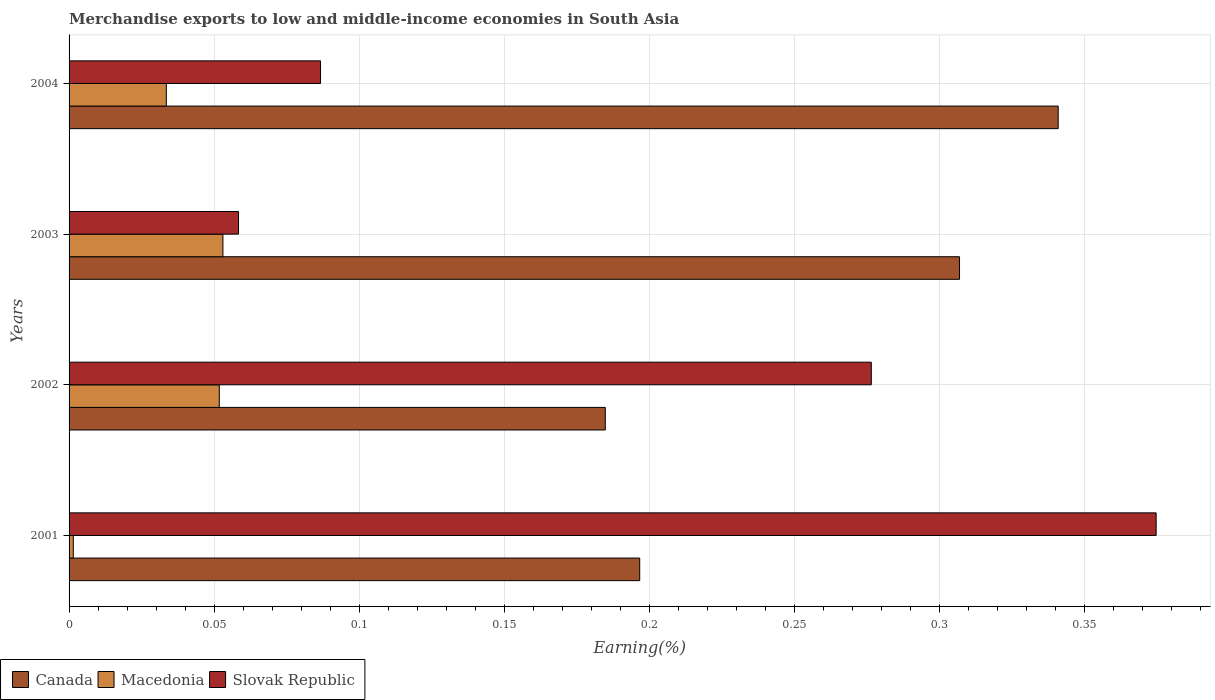Are the number of bars on each tick of the Y-axis equal?
Give a very brief answer. Yes. How many bars are there on the 1st tick from the top?
Ensure brevity in your answer.  3. What is the percentage of amount earned from merchandise exports in Canada in 2002?
Your response must be concise. 0.18. Across all years, what is the maximum percentage of amount earned from merchandise exports in Macedonia?
Make the answer very short. 0.05. Across all years, what is the minimum percentage of amount earned from merchandise exports in Macedonia?
Offer a very short reply. 0. What is the total percentage of amount earned from merchandise exports in Canada in the graph?
Ensure brevity in your answer.  1.03. What is the difference between the percentage of amount earned from merchandise exports in Macedonia in 2001 and that in 2003?
Your response must be concise. -0.05. What is the difference between the percentage of amount earned from merchandise exports in Canada in 2001 and the percentage of amount earned from merchandise exports in Slovak Republic in 2003?
Your answer should be compact. 0.14. What is the average percentage of amount earned from merchandise exports in Macedonia per year?
Your answer should be compact. 0.03. In the year 2001, what is the difference between the percentage of amount earned from merchandise exports in Canada and percentage of amount earned from merchandise exports in Macedonia?
Offer a very short reply. 0.2. What is the ratio of the percentage of amount earned from merchandise exports in Slovak Republic in 2001 to that in 2003?
Ensure brevity in your answer.  6.42. Is the difference between the percentage of amount earned from merchandise exports in Canada in 2001 and 2003 greater than the difference between the percentage of amount earned from merchandise exports in Macedonia in 2001 and 2003?
Give a very brief answer. No. What is the difference between the highest and the second highest percentage of amount earned from merchandise exports in Slovak Republic?
Keep it short and to the point. 0.1. What is the difference between the highest and the lowest percentage of amount earned from merchandise exports in Macedonia?
Offer a very short reply. 0.05. What does the 1st bar from the top in 2004 represents?
Offer a terse response. Slovak Republic. What does the 2nd bar from the bottom in 2003 represents?
Ensure brevity in your answer.  Macedonia. How many bars are there?
Your answer should be very brief. 12. Does the graph contain grids?
Ensure brevity in your answer.  Yes. What is the title of the graph?
Your response must be concise. Merchandise exports to low and middle-income economies in South Asia. What is the label or title of the X-axis?
Keep it short and to the point. Earning(%). What is the label or title of the Y-axis?
Your response must be concise. Years. What is the Earning(%) of Canada in 2001?
Keep it short and to the point. 0.2. What is the Earning(%) of Macedonia in 2001?
Provide a short and direct response. 0. What is the Earning(%) of Slovak Republic in 2001?
Your answer should be compact. 0.37. What is the Earning(%) of Canada in 2002?
Keep it short and to the point. 0.18. What is the Earning(%) of Macedonia in 2002?
Provide a succinct answer. 0.05. What is the Earning(%) of Slovak Republic in 2002?
Your answer should be very brief. 0.28. What is the Earning(%) in Canada in 2003?
Make the answer very short. 0.31. What is the Earning(%) of Macedonia in 2003?
Provide a succinct answer. 0.05. What is the Earning(%) of Slovak Republic in 2003?
Your answer should be compact. 0.06. What is the Earning(%) in Canada in 2004?
Keep it short and to the point. 0.34. What is the Earning(%) in Macedonia in 2004?
Make the answer very short. 0.03. What is the Earning(%) in Slovak Republic in 2004?
Give a very brief answer. 0.09. Across all years, what is the maximum Earning(%) of Canada?
Give a very brief answer. 0.34. Across all years, what is the maximum Earning(%) of Macedonia?
Give a very brief answer. 0.05. Across all years, what is the maximum Earning(%) of Slovak Republic?
Your response must be concise. 0.37. Across all years, what is the minimum Earning(%) in Canada?
Provide a succinct answer. 0.18. Across all years, what is the minimum Earning(%) of Macedonia?
Provide a short and direct response. 0. Across all years, what is the minimum Earning(%) of Slovak Republic?
Keep it short and to the point. 0.06. What is the total Earning(%) in Canada in the graph?
Ensure brevity in your answer.  1.03. What is the total Earning(%) in Macedonia in the graph?
Offer a terse response. 0.14. What is the total Earning(%) of Slovak Republic in the graph?
Your answer should be very brief. 0.8. What is the difference between the Earning(%) in Canada in 2001 and that in 2002?
Ensure brevity in your answer.  0.01. What is the difference between the Earning(%) in Macedonia in 2001 and that in 2002?
Keep it short and to the point. -0.05. What is the difference between the Earning(%) of Slovak Republic in 2001 and that in 2002?
Provide a short and direct response. 0.1. What is the difference between the Earning(%) of Canada in 2001 and that in 2003?
Your response must be concise. -0.11. What is the difference between the Earning(%) of Macedonia in 2001 and that in 2003?
Ensure brevity in your answer.  -0.05. What is the difference between the Earning(%) in Slovak Republic in 2001 and that in 2003?
Provide a succinct answer. 0.32. What is the difference between the Earning(%) of Canada in 2001 and that in 2004?
Your answer should be very brief. -0.14. What is the difference between the Earning(%) of Macedonia in 2001 and that in 2004?
Your answer should be very brief. -0.03. What is the difference between the Earning(%) in Slovak Republic in 2001 and that in 2004?
Your response must be concise. 0.29. What is the difference between the Earning(%) of Canada in 2002 and that in 2003?
Offer a terse response. -0.12. What is the difference between the Earning(%) of Macedonia in 2002 and that in 2003?
Provide a succinct answer. -0. What is the difference between the Earning(%) of Slovak Republic in 2002 and that in 2003?
Make the answer very short. 0.22. What is the difference between the Earning(%) of Canada in 2002 and that in 2004?
Your answer should be compact. -0.16. What is the difference between the Earning(%) of Macedonia in 2002 and that in 2004?
Offer a very short reply. 0.02. What is the difference between the Earning(%) of Slovak Republic in 2002 and that in 2004?
Ensure brevity in your answer.  0.19. What is the difference between the Earning(%) of Canada in 2003 and that in 2004?
Offer a terse response. -0.03. What is the difference between the Earning(%) in Macedonia in 2003 and that in 2004?
Make the answer very short. 0.02. What is the difference between the Earning(%) of Slovak Republic in 2003 and that in 2004?
Offer a terse response. -0.03. What is the difference between the Earning(%) in Canada in 2001 and the Earning(%) in Macedonia in 2002?
Offer a very short reply. 0.14. What is the difference between the Earning(%) in Canada in 2001 and the Earning(%) in Slovak Republic in 2002?
Make the answer very short. -0.08. What is the difference between the Earning(%) in Macedonia in 2001 and the Earning(%) in Slovak Republic in 2002?
Your answer should be compact. -0.28. What is the difference between the Earning(%) of Canada in 2001 and the Earning(%) of Macedonia in 2003?
Ensure brevity in your answer.  0.14. What is the difference between the Earning(%) in Canada in 2001 and the Earning(%) in Slovak Republic in 2003?
Provide a succinct answer. 0.14. What is the difference between the Earning(%) of Macedonia in 2001 and the Earning(%) of Slovak Republic in 2003?
Your answer should be very brief. -0.06. What is the difference between the Earning(%) in Canada in 2001 and the Earning(%) in Macedonia in 2004?
Provide a succinct answer. 0.16. What is the difference between the Earning(%) of Canada in 2001 and the Earning(%) of Slovak Republic in 2004?
Keep it short and to the point. 0.11. What is the difference between the Earning(%) of Macedonia in 2001 and the Earning(%) of Slovak Republic in 2004?
Offer a very short reply. -0.09. What is the difference between the Earning(%) in Canada in 2002 and the Earning(%) in Macedonia in 2003?
Offer a very short reply. 0.13. What is the difference between the Earning(%) of Canada in 2002 and the Earning(%) of Slovak Republic in 2003?
Offer a terse response. 0.13. What is the difference between the Earning(%) in Macedonia in 2002 and the Earning(%) in Slovak Republic in 2003?
Your answer should be compact. -0.01. What is the difference between the Earning(%) in Canada in 2002 and the Earning(%) in Macedonia in 2004?
Provide a succinct answer. 0.15. What is the difference between the Earning(%) in Canada in 2002 and the Earning(%) in Slovak Republic in 2004?
Provide a short and direct response. 0.1. What is the difference between the Earning(%) of Macedonia in 2002 and the Earning(%) of Slovak Republic in 2004?
Offer a terse response. -0.03. What is the difference between the Earning(%) of Canada in 2003 and the Earning(%) of Macedonia in 2004?
Keep it short and to the point. 0.27. What is the difference between the Earning(%) in Canada in 2003 and the Earning(%) in Slovak Republic in 2004?
Offer a very short reply. 0.22. What is the difference between the Earning(%) in Macedonia in 2003 and the Earning(%) in Slovak Republic in 2004?
Make the answer very short. -0.03. What is the average Earning(%) in Canada per year?
Offer a terse response. 0.26. What is the average Earning(%) in Macedonia per year?
Your response must be concise. 0.04. What is the average Earning(%) in Slovak Republic per year?
Make the answer very short. 0.2. In the year 2001, what is the difference between the Earning(%) of Canada and Earning(%) of Macedonia?
Your response must be concise. 0.2. In the year 2001, what is the difference between the Earning(%) of Canada and Earning(%) of Slovak Republic?
Offer a very short reply. -0.18. In the year 2001, what is the difference between the Earning(%) in Macedonia and Earning(%) in Slovak Republic?
Offer a terse response. -0.37. In the year 2002, what is the difference between the Earning(%) in Canada and Earning(%) in Macedonia?
Make the answer very short. 0.13. In the year 2002, what is the difference between the Earning(%) of Canada and Earning(%) of Slovak Republic?
Give a very brief answer. -0.09. In the year 2002, what is the difference between the Earning(%) in Macedonia and Earning(%) in Slovak Republic?
Offer a very short reply. -0.22. In the year 2003, what is the difference between the Earning(%) in Canada and Earning(%) in Macedonia?
Offer a terse response. 0.25. In the year 2003, what is the difference between the Earning(%) of Canada and Earning(%) of Slovak Republic?
Provide a succinct answer. 0.25. In the year 2003, what is the difference between the Earning(%) in Macedonia and Earning(%) in Slovak Republic?
Provide a short and direct response. -0.01. In the year 2004, what is the difference between the Earning(%) in Canada and Earning(%) in Macedonia?
Make the answer very short. 0.31. In the year 2004, what is the difference between the Earning(%) of Canada and Earning(%) of Slovak Republic?
Ensure brevity in your answer.  0.25. In the year 2004, what is the difference between the Earning(%) in Macedonia and Earning(%) in Slovak Republic?
Keep it short and to the point. -0.05. What is the ratio of the Earning(%) in Canada in 2001 to that in 2002?
Keep it short and to the point. 1.06. What is the ratio of the Earning(%) of Macedonia in 2001 to that in 2002?
Provide a succinct answer. 0.03. What is the ratio of the Earning(%) of Slovak Republic in 2001 to that in 2002?
Provide a short and direct response. 1.36. What is the ratio of the Earning(%) in Canada in 2001 to that in 2003?
Offer a very short reply. 0.64. What is the ratio of the Earning(%) of Macedonia in 2001 to that in 2003?
Make the answer very short. 0.03. What is the ratio of the Earning(%) in Slovak Republic in 2001 to that in 2003?
Provide a short and direct response. 6.42. What is the ratio of the Earning(%) of Canada in 2001 to that in 2004?
Your response must be concise. 0.58. What is the ratio of the Earning(%) in Macedonia in 2001 to that in 2004?
Offer a terse response. 0.04. What is the ratio of the Earning(%) of Slovak Republic in 2001 to that in 2004?
Your answer should be very brief. 4.32. What is the ratio of the Earning(%) of Canada in 2002 to that in 2003?
Your response must be concise. 0.6. What is the ratio of the Earning(%) in Macedonia in 2002 to that in 2003?
Your answer should be compact. 0.98. What is the ratio of the Earning(%) in Slovak Republic in 2002 to that in 2003?
Keep it short and to the point. 4.73. What is the ratio of the Earning(%) in Canada in 2002 to that in 2004?
Make the answer very short. 0.54. What is the ratio of the Earning(%) in Macedonia in 2002 to that in 2004?
Provide a succinct answer. 1.54. What is the ratio of the Earning(%) of Slovak Republic in 2002 to that in 2004?
Offer a terse response. 3.19. What is the ratio of the Earning(%) in Canada in 2003 to that in 2004?
Your response must be concise. 0.9. What is the ratio of the Earning(%) in Macedonia in 2003 to that in 2004?
Your answer should be very brief. 1.58. What is the ratio of the Earning(%) of Slovak Republic in 2003 to that in 2004?
Keep it short and to the point. 0.67. What is the difference between the highest and the second highest Earning(%) in Canada?
Your response must be concise. 0.03. What is the difference between the highest and the second highest Earning(%) in Macedonia?
Ensure brevity in your answer.  0. What is the difference between the highest and the second highest Earning(%) of Slovak Republic?
Make the answer very short. 0.1. What is the difference between the highest and the lowest Earning(%) of Canada?
Offer a terse response. 0.16. What is the difference between the highest and the lowest Earning(%) in Macedonia?
Your response must be concise. 0.05. What is the difference between the highest and the lowest Earning(%) in Slovak Republic?
Ensure brevity in your answer.  0.32. 